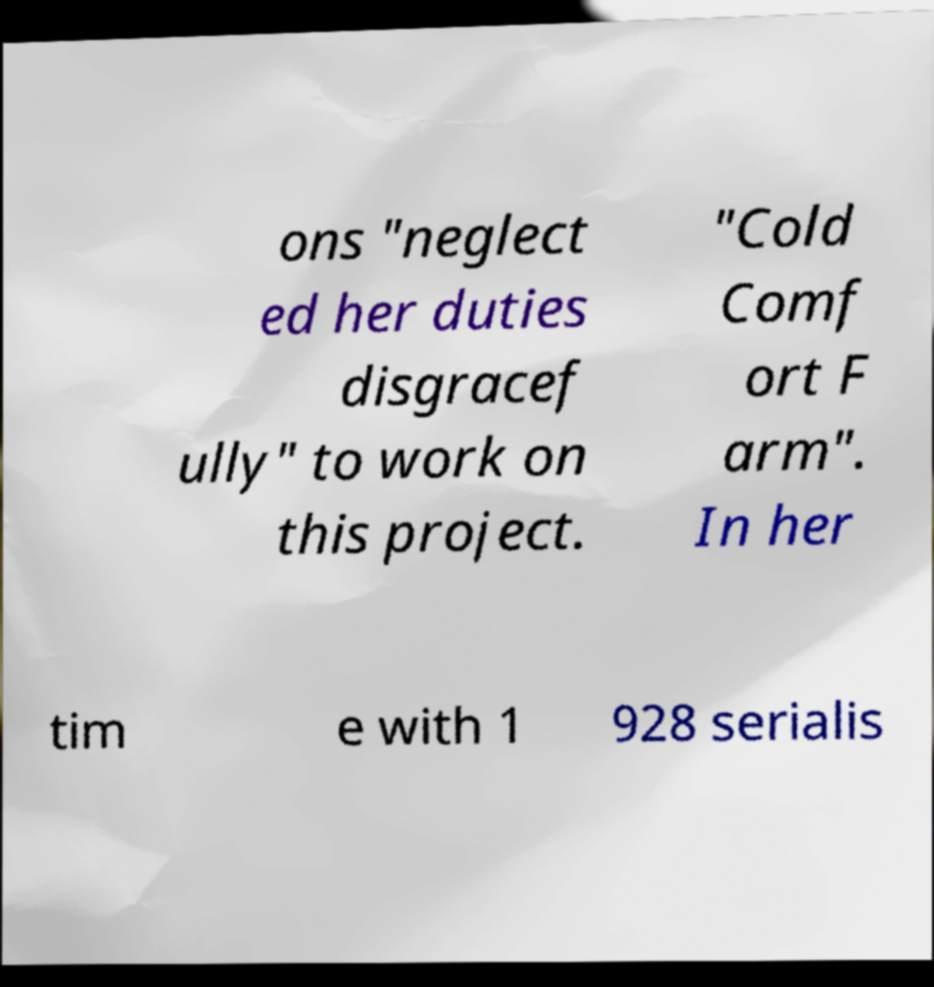For documentation purposes, I need the text within this image transcribed. Could you provide that? ons "neglect ed her duties disgracef ully" to work on this project. "Cold Comf ort F arm". In her tim e with 1 928 serialis 